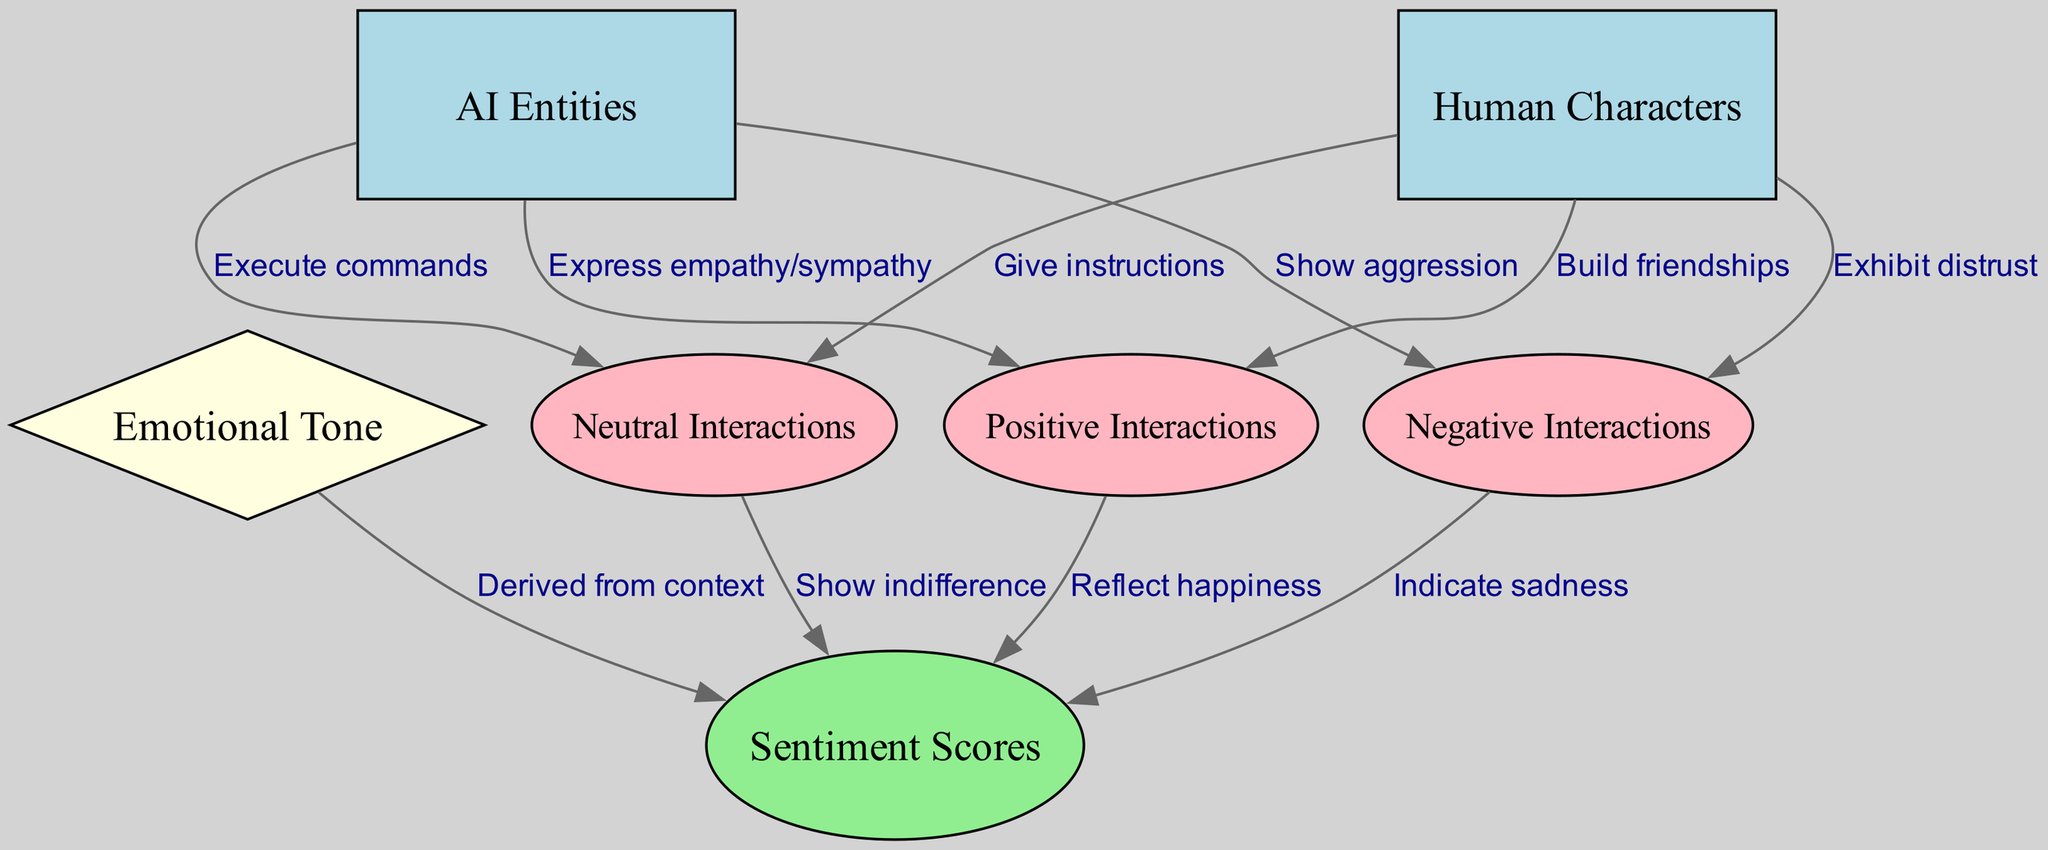What is the total number of nodes in the diagram? The diagram includes six nodes labeled AI Entities, Human Characters, Emotional Tone, Positive Interactions, Negative Interactions, Neutral Interactions, and Sentiment Scores. Counting these nodes results in a total of six nodes.
Answer: 6 What type of interaction do AI Entities show towards Negative Interactions? The diagram indicates that AI Entities show aggression towards Negative Interactions, as represented by the edge labeled "Show aggression."
Answer: aggression Which node reflects happiness? The Positive Interactions node is connected to the Sentiment Scores node with the label "Reflect happiness," indicating that it is the source for happiness in sentiment scores.
Answer: Positive Interactions How do Human Characters generally interact positively? Human Characters build friendships, as indicated by the edge linking Human Characters to Positive Interactions with the label "Build friendships."
Answer: Build friendships What is the emotional tone derived from? The Emotional Tone node receives input to Sentiment Scores, derived from context, as shown in the edge labeled "Derived from context."
Answer: context Which interactions indicate sadness in sentiment scores? The diagram shows that Negative Interactions indicate sadness, as it is connected to Sentiment Scores with the label "Indicate sadness."
Answer: Negative Interactions How many types of interactions are presented in the diagram? There are three types of interactions shown in the diagram: Positive, Negative, and Neutral Interactions, making a total of three types.
Answer: 3 What emotional tone does the Neutral Interactions node show? Neutral Interactions show indifference, according to the edge labeled "Show indifference" that connects it to Sentiment Scores.
Answer: indifference In total, how many edges connect nodes in the diagram? The diagram contains a total of nine edges connecting various nodes, illustrating the relationships and interactions among them.
Answer: 9 